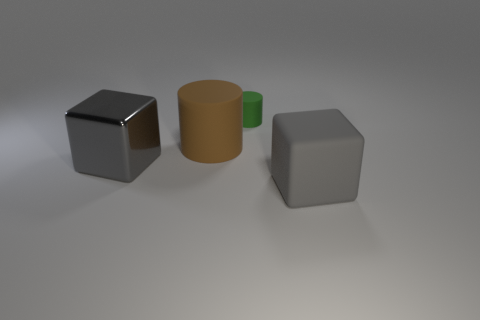What shape is the gray metal thing that is to the left of the large gray thing that is in front of the large gray shiny thing?
Offer a very short reply. Cube. The matte thing that is both behind the big gray metallic thing and on the right side of the brown rubber cylinder has what shape?
Offer a terse response. Cylinder. What number of things are big brown rubber balls or cylinders behind the large brown matte thing?
Your response must be concise. 1. There is another thing that is the same shape as the tiny object; what is it made of?
Your answer should be very brief. Rubber. There is a thing that is in front of the green rubber object and behind the gray metal cube; what is it made of?
Give a very brief answer. Rubber. What number of red metal things have the same shape as the big brown matte object?
Ensure brevity in your answer.  0. What color is the large cube that is behind the big gray object right of the big gray metal thing?
Make the answer very short. Gray. Are there an equal number of large things that are right of the gray rubber object and big cyan blocks?
Offer a terse response. Yes. Is there a cyan matte object of the same size as the brown cylinder?
Your answer should be compact. No. There is a metallic cube; is its size the same as the rubber object on the right side of the green object?
Provide a succinct answer. Yes. 